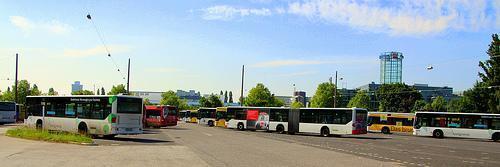How many buses are yellow?
Give a very brief answer. 3. 